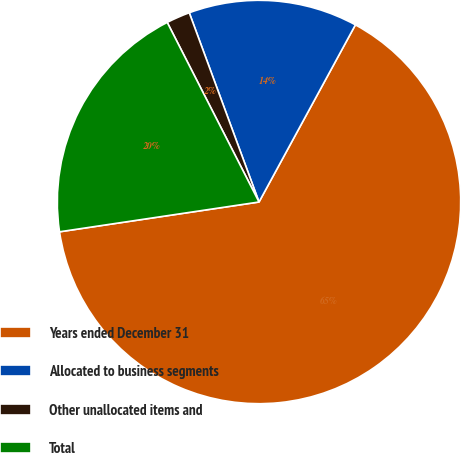Convert chart to OTSL. <chart><loc_0><loc_0><loc_500><loc_500><pie_chart><fcel>Years ended December 31<fcel>Allocated to business segments<fcel>Other unallocated items and<fcel>Total<nl><fcel>64.71%<fcel>13.55%<fcel>1.9%<fcel>19.84%<nl></chart> 